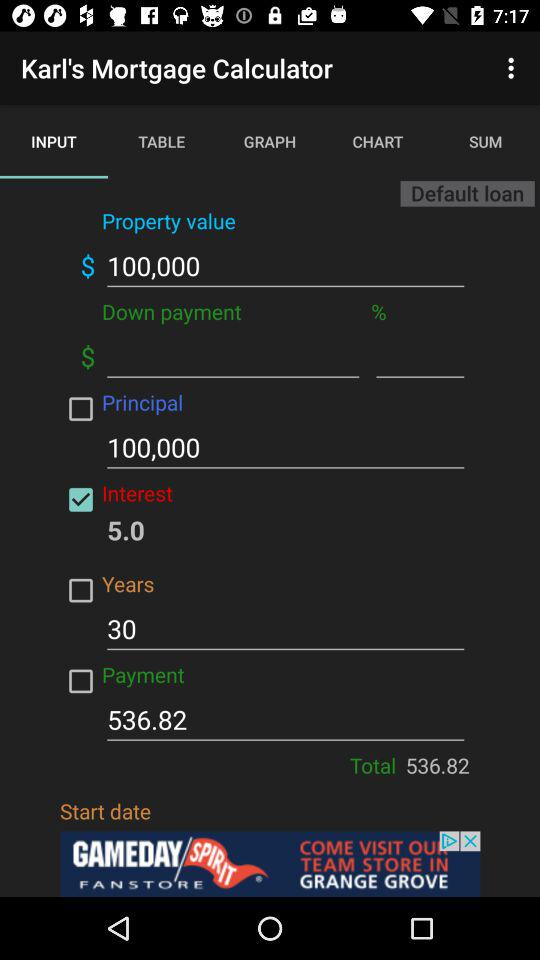How much is the principal amount? The principal amount is 100,000. 